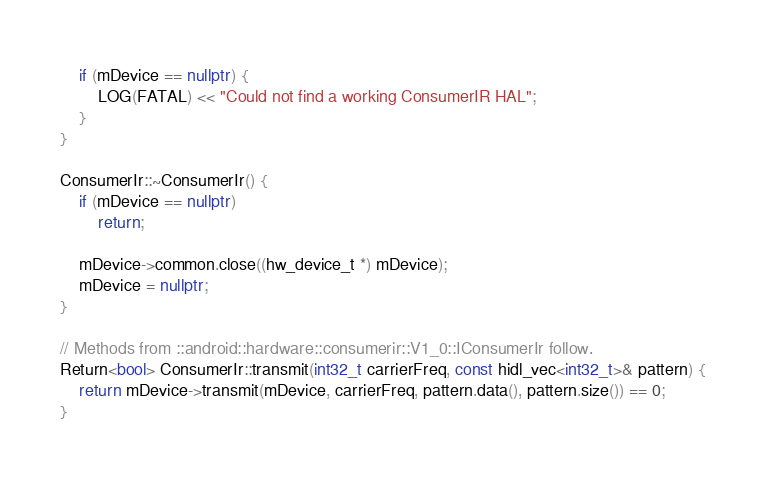Convert code to text. <code><loc_0><loc_0><loc_500><loc_500><_C++_>
    if (mDevice == nullptr) {
        LOG(FATAL) << "Could not find a working ConsumerIR HAL";
    }
}

ConsumerIr::~ConsumerIr() {
    if (mDevice == nullptr)
        return;

    mDevice->common.close((hw_device_t *) mDevice);
    mDevice = nullptr;
}

// Methods from ::android::hardware::consumerir::V1_0::IConsumerIr follow.
Return<bool> ConsumerIr::transmit(int32_t carrierFreq, const hidl_vec<int32_t>& pattern) {
    return mDevice->transmit(mDevice, carrierFreq, pattern.data(), pattern.size()) == 0;
}
</code> 